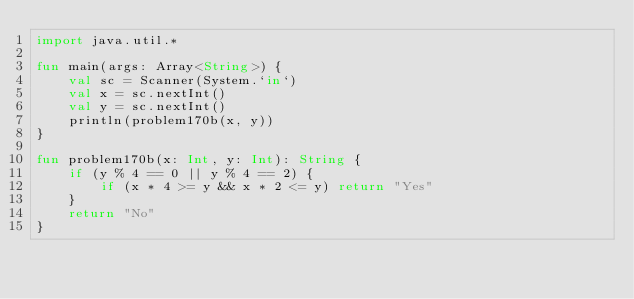Convert code to text. <code><loc_0><loc_0><loc_500><loc_500><_Kotlin_>import java.util.*

fun main(args: Array<String>) {
    val sc = Scanner(System.`in`)
    val x = sc.nextInt()
    val y = sc.nextInt()
    println(problem170b(x, y))
}

fun problem170b(x: Int, y: Int): String {
    if (y % 4 == 0 || y % 4 == 2) {
        if (x * 4 >= y && x * 2 <= y) return "Yes"
    }
    return "No"
}</code> 